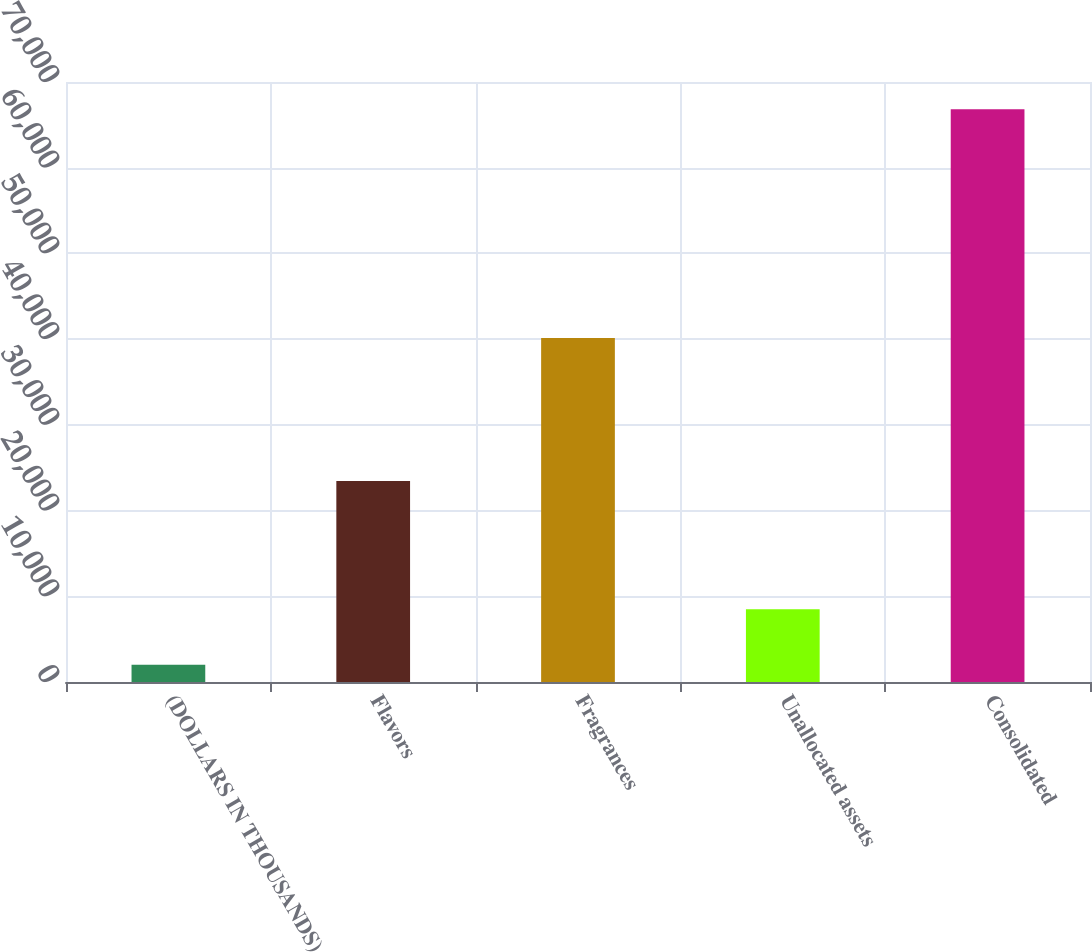<chart> <loc_0><loc_0><loc_500><loc_500><bar_chart><fcel>(DOLLARS IN THOUSANDS)<fcel>Flavors<fcel>Fragrances<fcel>Unallocated assets<fcel>Consolidated<nl><fcel>2009<fcel>23463<fcel>40122<fcel>8490<fcel>66819<nl></chart> 